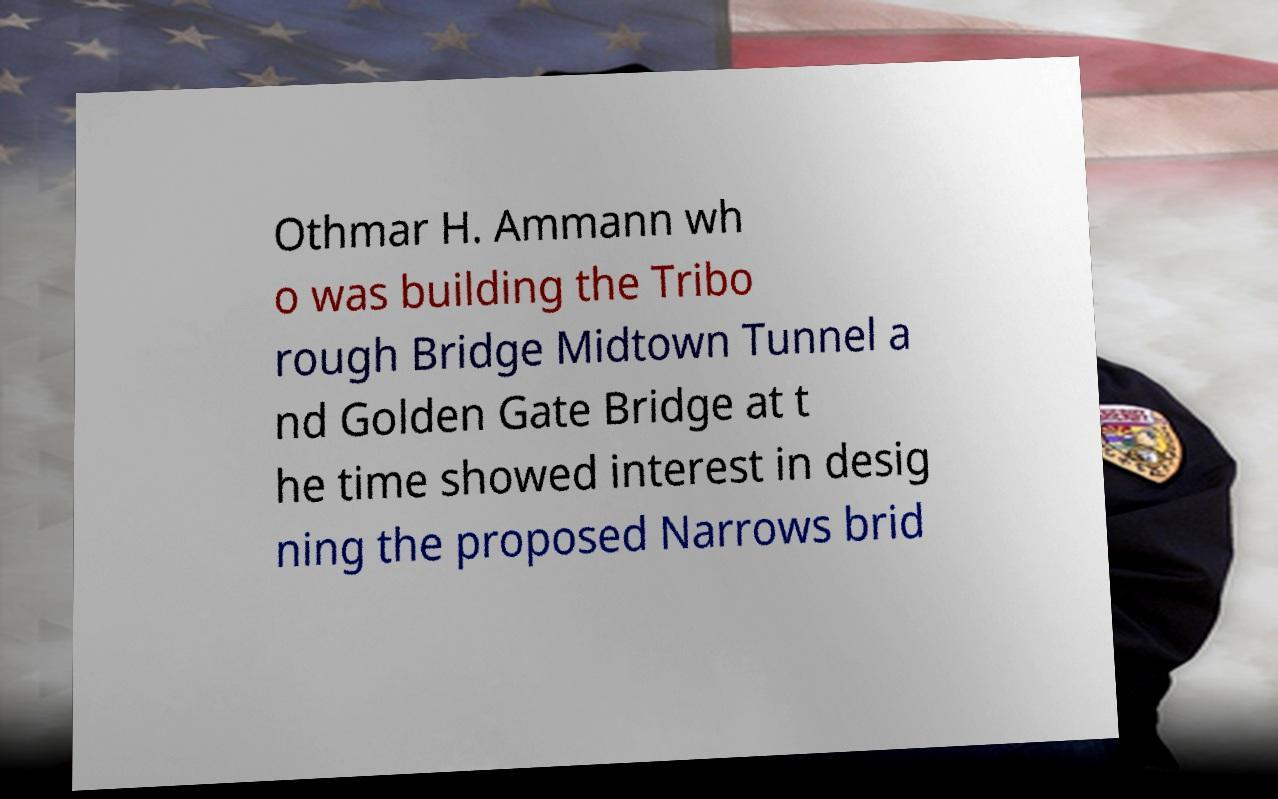There's text embedded in this image that I need extracted. Can you transcribe it verbatim? Othmar H. Ammann wh o was building the Tribo rough Bridge Midtown Tunnel a nd Golden Gate Bridge at t he time showed interest in desig ning the proposed Narrows brid 